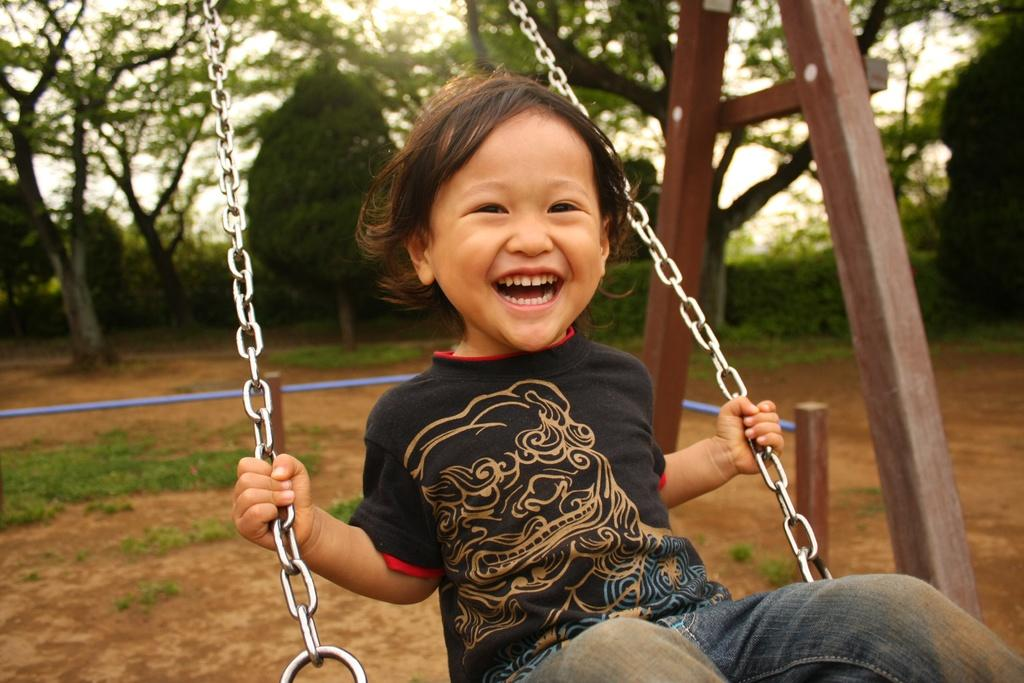What is the main subject of the image? The main subject of the image is a kid. What is the kid doing in the image? The kid is swinging on a cradle. Can you describe any objects in the image? There is a blue color object and a wooden stick in the image. What can be seen in the background of the image? Trees and grass are visible in the background of the image. What type of toothpaste is the kid using while swinging on the cradle? There is no toothpaste present in the image, and the kid is not using any toothpaste while swinging on the cradle. 